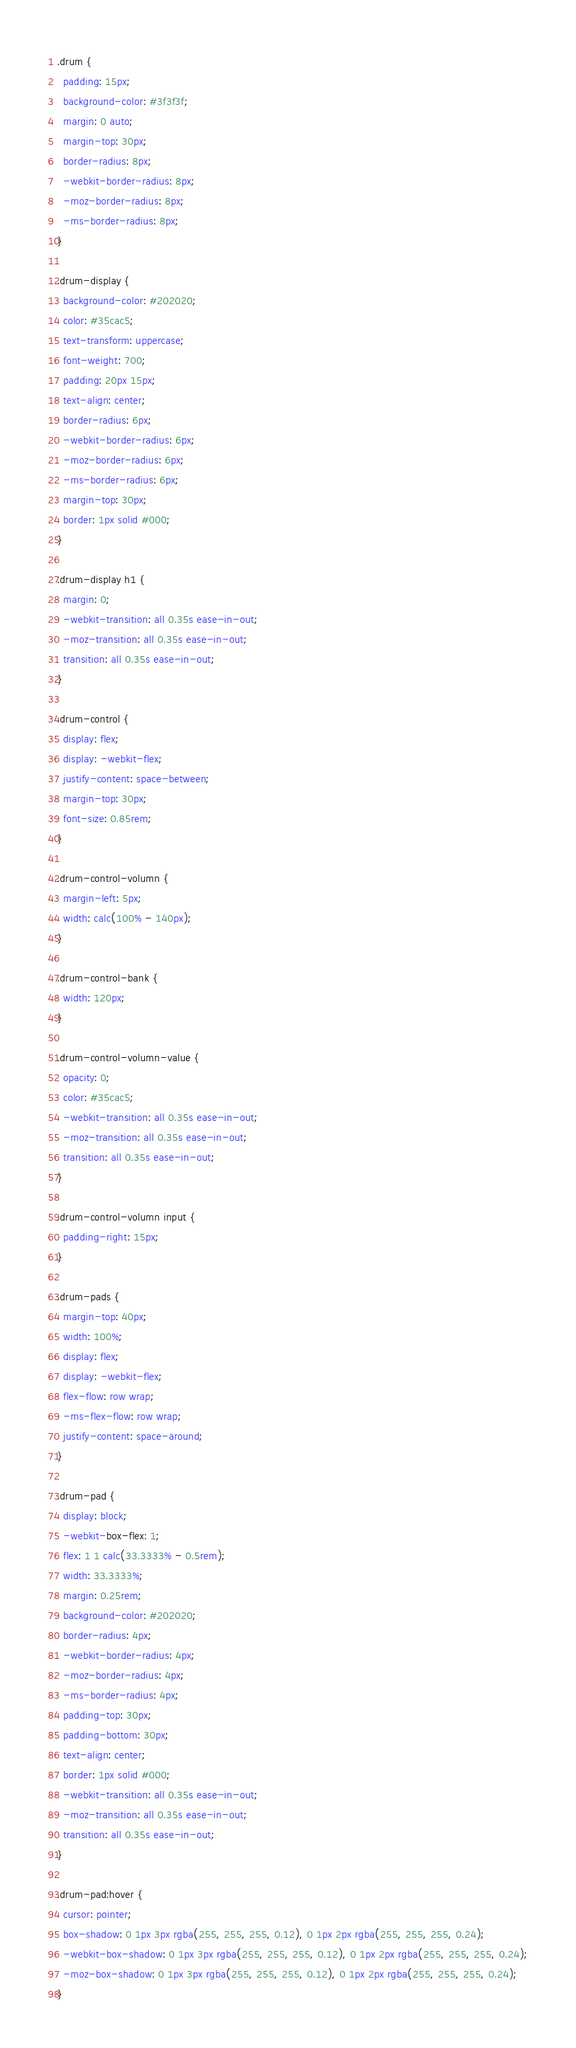Convert code to text. <code><loc_0><loc_0><loc_500><loc_500><_CSS_>.drum {
  padding: 15px;
  background-color: #3f3f3f;
  margin: 0 auto;
  margin-top: 30px;
  border-radius: 8px;
  -webkit-border-radius: 8px;
  -moz-border-radius: 8px;
  -ms-border-radius: 8px;
}

.drum-display {
  background-color: #202020;
  color: #35cac5;
  text-transform: uppercase;
  font-weight: 700;
  padding: 20px 15px;
  text-align: center;
  border-radius: 6px;
  -webkit-border-radius: 6px;
  -moz-border-radius: 6px;
  -ms-border-radius: 6px;
  margin-top: 30px;
  border: 1px solid #000;
}

.drum-display h1 {
  margin: 0;
  -webkit-transition: all 0.35s ease-in-out;
  -moz-transition: all 0.35s ease-in-out;
  transition: all 0.35s ease-in-out;
}

.drum-control {
  display: flex;
  display: -webkit-flex;
  justify-content: space-between;
  margin-top: 30px;
  font-size: 0.85rem;
}

.drum-control-volumn {
  margin-left: 5px;
  width: calc(100% - 140px);
}

.drum-control-bank {
  width: 120px;
}

.drum-control-volumn-value {
  opacity: 0;
  color: #35cac5;
  -webkit-transition: all 0.35s ease-in-out;
  -moz-transition: all 0.35s ease-in-out;
  transition: all 0.35s ease-in-out;
}

.drum-control-volumn input {
  padding-right: 15px;
}

.drum-pads {
  margin-top: 40px;
  width: 100%;
  display: flex;
  display: -webkit-flex;
  flex-flow: row wrap;
  -ms-flex-flow: row wrap;
  justify-content: space-around;
}

.drum-pad {
  display: block;
  -webkit-box-flex: 1;
  flex: 1 1 calc(33.3333% - 0.5rem);
  width: 33.3333%;
  margin: 0.25rem;
  background-color: #202020;
  border-radius: 4px;
  -webkit-border-radius: 4px;
  -moz-border-radius: 4px;
  -ms-border-radius: 4px;
  padding-top: 30px;
  padding-bottom: 30px;
  text-align: center;
  border: 1px solid #000;
  -webkit-transition: all 0.35s ease-in-out;
  -moz-transition: all 0.35s ease-in-out;
  transition: all 0.35s ease-in-out;
}

.drum-pad:hover {
  cursor: pointer;
  box-shadow: 0 1px 3px rgba(255, 255, 255, 0.12), 0 1px 2px rgba(255, 255, 255, 0.24);
  -webkit-box-shadow: 0 1px 3px rgba(255, 255, 255, 0.12), 0 1px 2px rgba(255, 255, 255, 0.24);
  -moz-box-shadow: 0 1px 3px rgba(255, 255, 255, 0.12), 0 1px 2px rgba(255, 255, 255, 0.24);
}
</code> 